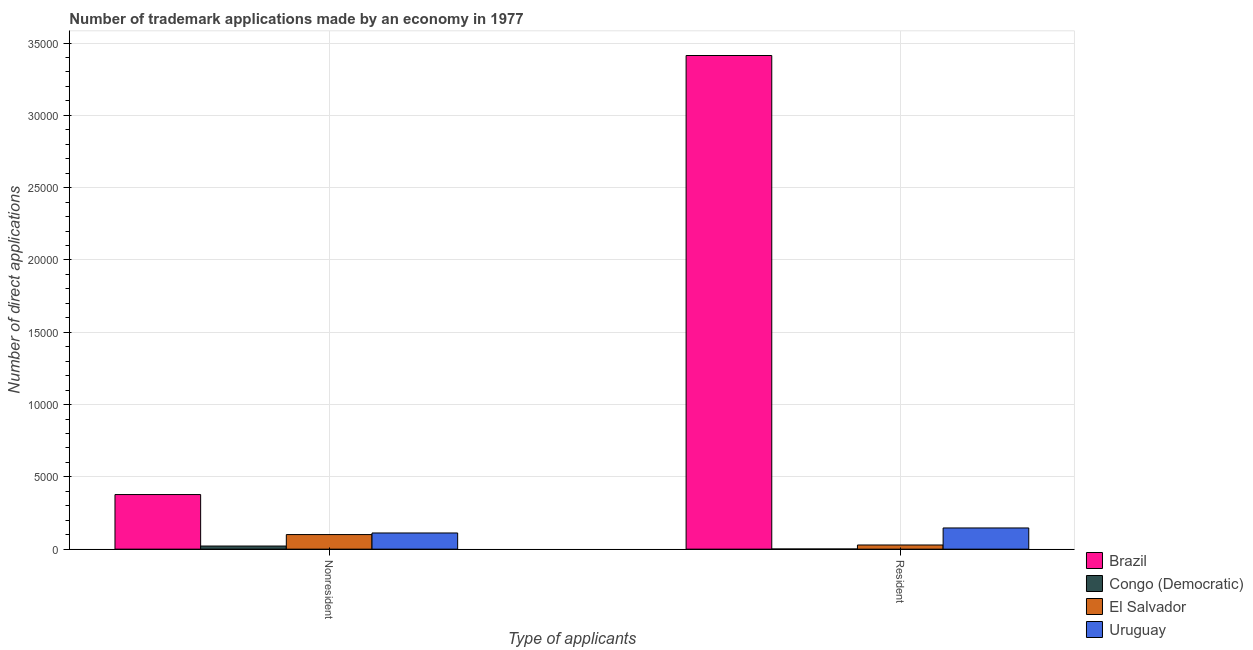How many different coloured bars are there?
Give a very brief answer. 4. How many groups of bars are there?
Provide a succinct answer. 2. Are the number of bars per tick equal to the number of legend labels?
Give a very brief answer. Yes. Are the number of bars on each tick of the X-axis equal?
Your answer should be very brief. Yes. How many bars are there on the 1st tick from the right?
Offer a terse response. 4. What is the label of the 1st group of bars from the left?
Ensure brevity in your answer.  Nonresident. What is the number of trademark applications made by non residents in El Salvador?
Make the answer very short. 1008. Across all countries, what is the maximum number of trademark applications made by residents?
Ensure brevity in your answer.  3.41e+04. Across all countries, what is the minimum number of trademark applications made by residents?
Offer a very short reply. 10. In which country was the number of trademark applications made by residents minimum?
Keep it short and to the point. Congo (Democratic). What is the total number of trademark applications made by residents in the graph?
Give a very brief answer. 3.59e+04. What is the difference between the number of trademark applications made by residents in Congo (Democratic) and that in Brazil?
Provide a succinct answer. -3.41e+04. What is the difference between the number of trademark applications made by non residents in Brazil and the number of trademark applications made by residents in El Salvador?
Your response must be concise. 3489. What is the average number of trademark applications made by non residents per country?
Ensure brevity in your answer.  1529.5. What is the difference between the number of trademark applications made by residents and number of trademark applications made by non residents in Congo (Democratic)?
Offer a very short reply. -205. In how many countries, is the number of trademark applications made by non residents greater than 2000 ?
Ensure brevity in your answer.  1. What is the ratio of the number of trademark applications made by residents in El Salvador to that in Brazil?
Offer a terse response. 0.01. Is the number of trademark applications made by residents in El Salvador less than that in Congo (Democratic)?
Your answer should be very brief. No. In how many countries, is the number of trademark applications made by non residents greater than the average number of trademark applications made by non residents taken over all countries?
Provide a succinct answer. 1. What does the 2nd bar from the left in Resident represents?
Your answer should be compact. Congo (Democratic). What does the 3rd bar from the right in Resident represents?
Give a very brief answer. Congo (Democratic). How many bars are there?
Make the answer very short. 8. How many countries are there in the graph?
Your answer should be compact. 4. What is the difference between two consecutive major ticks on the Y-axis?
Ensure brevity in your answer.  5000. Are the values on the major ticks of Y-axis written in scientific E-notation?
Provide a short and direct response. No. Does the graph contain any zero values?
Your answer should be compact. No. Does the graph contain grids?
Ensure brevity in your answer.  Yes. What is the title of the graph?
Ensure brevity in your answer.  Number of trademark applications made by an economy in 1977. Does "Philippines" appear as one of the legend labels in the graph?
Offer a terse response. No. What is the label or title of the X-axis?
Offer a very short reply. Type of applicants. What is the label or title of the Y-axis?
Keep it short and to the point. Number of direct applications. What is the Number of direct applications in Brazil in Nonresident?
Provide a short and direct response. 3776. What is the Number of direct applications in Congo (Democratic) in Nonresident?
Offer a terse response. 215. What is the Number of direct applications in El Salvador in Nonresident?
Your answer should be compact. 1008. What is the Number of direct applications of Uruguay in Nonresident?
Provide a succinct answer. 1119. What is the Number of direct applications in Brazil in Resident?
Offer a terse response. 3.41e+04. What is the Number of direct applications in El Salvador in Resident?
Provide a short and direct response. 287. What is the Number of direct applications of Uruguay in Resident?
Your answer should be very brief. 1465. Across all Type of applicants, what is the maximum Number of direct applications of Brazil?
Provide a short and direct response. 3.41e+04. Across all Type of applicants, what is the maximum Number of direct applications of Congo (Democratic)?
Your response must be concise. 215. Across all Type of applicants, what is the maximum Number of direct applications of El Salvador?
Provide a short and direct response. 1008. Across all Type of applicants, what is the maximum Number of direct applications of Uruguay?
Make the answer very short. 1465. Across all Type of applicants, what is the minimum Number of direct applications of Brazil?
Provide a short and direct response. 3776. Across all Type of applicants, what is the minimum Number of direct applications in El Salvador?
Offer a very short reply. 287. Across all Type of applicants, what is the minimum Number of direct applications in Uruguay?
Make the answer very short. 1119. What is the total Number of direct applications in Brazil in the graph?
Provide a succinct answer. 3.79e+04. What is the total Number of direct applications of Congo (Democratic) in the graph?
Ensure brevity in your answer.  225. What is the total Number of direct applications in El Salvador in the graph?
Your response must be concise. 1295. What is the total Number of direct applications of Uruguay in the graph?
Offer a terse response. 2584. What is the difference between the Number of direct applications of Brazil in Nonresident and that in Resident?
Your answer should be compact. -3.04e+04. What is the difference between the Number of direct applications in Congo (Democratic) in Nonresident and that in Resident?
Give a very brief answer. 205. What is the difference between the Number of direct applications of El Salvador in Nonresident and that in Resident?
Provide a short and direct response. 721. What is the difference between the Number of direct applications in Uruguay in Nonresident and that in Resident?
Your answer should be compact. -346. What is the difference between the Number of direct applications in Brazil in Nonresident and the Number of direct applications in Congo (Democratic) in Resident?
Your answer should be compact. 3766. What is the difference between the Number of direct applications of Brazil in Nonresident and the Number of direct applications of El Salvador in Resident?
Your answer should be very brief. 3489. What is the difference between the Number of direct applications of Brazil in Nonresident and the Number of direct applications of Uruguay in Resident?
Make the answer very short. 2311. What is the difference between the Number of direct applications of Congo (Democratic) in Nonresident and the Number of direct applications of El Salvador in Resident?
Ensure brevity in your answer.  -72. What is the difference between the Number of direct applications of Congo (Democratic) in Nonresident and the Number of direct applications of Uruguay in Resident?
Offer a very short reply. -1250. What is the difference between the Number of direct applications in El Salvador in Nonresident and the Number of direct applications in Uruguay in Resident?
Offer a terse response. -457. What is the average Number of direct applications of Brazil per Type of applicants?
Ensure brevity in your answer.  1.90e+04. What is the average Number of direct applications of Congo (Democratic) per Type of applicants?
Make the answer very short. 112.5. What is the average Number of direct applications of El Salvador per Type of applicants?
Offer a very short reply. 647.5. What is the average Number of direct applications in Uruguay per Type of applicants?
Ensure brevity in your answer.  1292. What is the difference between the Number of direct applications in Brazil and Number of direct applications in Congo (Democratic) in Nonresident?
Ensure brevity in your answer.  3561. What is the difference between the Number of direct applications in Brazil and Number of direct applications in El Salvador in Nonresident?
Your answer should be very brief. 2768. What is the difference between the Number of direct applications of Brazil and Number of direct applications of Uruguay in Nonresident?
Provide a short and direct response. 2657. What is the difference between the Number of direct applications in Congo (Democratic) and Number of direct applications in El Salvador in Nonresident?
Provide a short and direct response. -793. What is the difference between the Number of direct applications of Congo (Democratic) and Number of direct applications of Uruguay in Nonresident?
Ensure brevity in your answer.  -904. What is the difference between the Number of direct applications in El Salvador and Number of direct applications in Uruguay in Nonresident?
Keep it short and to the point. -111. What is the difference between the Number of direct applications in Brazil and Number of direct applications in Congo (Democratic) in Resident?
Ensure brevity in your answer.  3.41e+04. What is the difference between the Number of direct applications of Brazil and Number of direct applications of El Salvador in Resident?
Your answer should be compact. 3.39e+04. What is the difference between the Number of direct applications of Brazil and Number of direct applications of Uruguay in Resident?
Make the answer very short. 3.27e+04. What is the difference between the Number of direct applications in Congo (Democratic) and Number of direct applications in El Salvador in Resident?
Your answer should be compact. -277. What is the difference between the Number of direct applications in Congo (Democratic) and Number of direct applications in Uruguay in Resident?
Give a very brief answer. -1455. What is the difference between the Number of direct applications of El Salvador and Number of direct applications of Uruguay in Resident?
Provide a succinct answer. -1178. What is the ratio of the Number of direct applications of Brazil in Nonresident to that in Resident?
Keep it short and to the point. 0.11. What is the ratio of the Number of direct applications in Congo (Democratic) in Nonresident to that in Resident?
Give a very brief answer. 21.5. What is the ratio of the Number of direct applications of El Salvador in Nonresident to that in Resident?
Provide a succinct answer. 3.51. What is the ratio of the Number of direct applications in Uruguay in Nonresident to that in Resident?
Your answer should be very brief. 0.76. What is the difference between the highest and the second highest Number of direct applications of Brazil?
Your answer should be compact. 3.04e+04. What is the difference between the highest and the second highest Number of direct applications in Congo (Democratic)?
Ensure brevity in your answer.  205. What is the difference between the highest and the second highest Number of direct applications of El Salvador?
Your response must be concise. 721. What is the difference between the highest and the second highest Number of direct applications of Uruguay?
Provide a short and direct response. 346. What is the difference between the highest and the lowest Number of direct applications of Brazil?
Ensure brevity in your answer.  3.04e+04. What is the difference between the highest and the lowest Number of direct applications in Congo (Democratic)?
Offer a terse response. 205. What is the difference between the highest and the lowest Number of direct applications in El Salvador?
Keep it short and to the point. 721. What is the difference between the highest and the lowest Number of direct applications in Uruguay?
Provide a succinct answer. 346. 